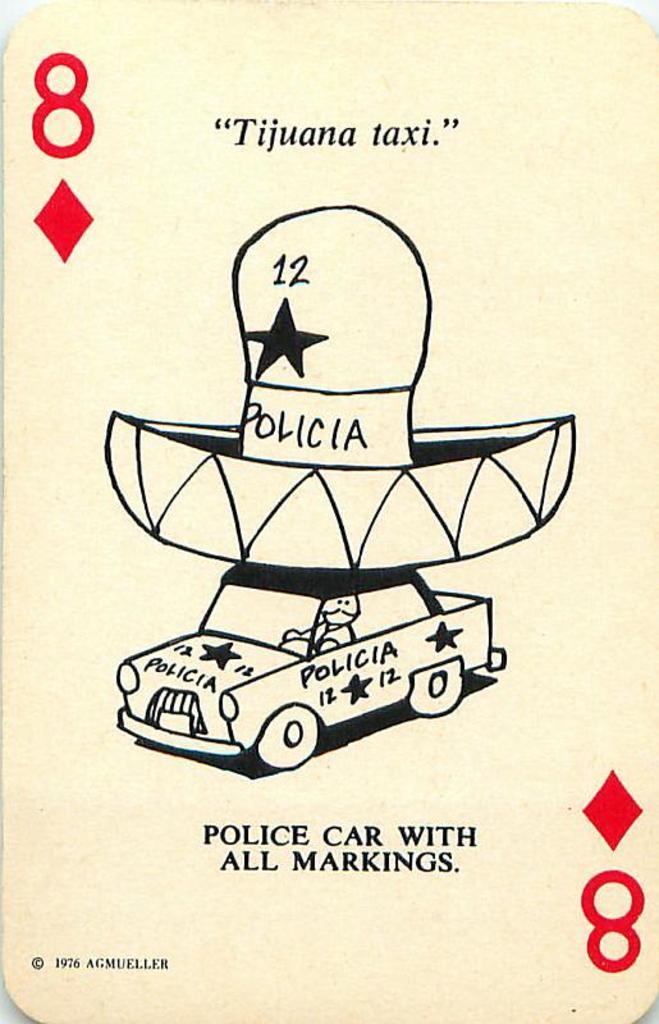Could you give a brief overview of what you see in this image? In this image I can see a poster in which I can see a car. I can also see some text written on it. 